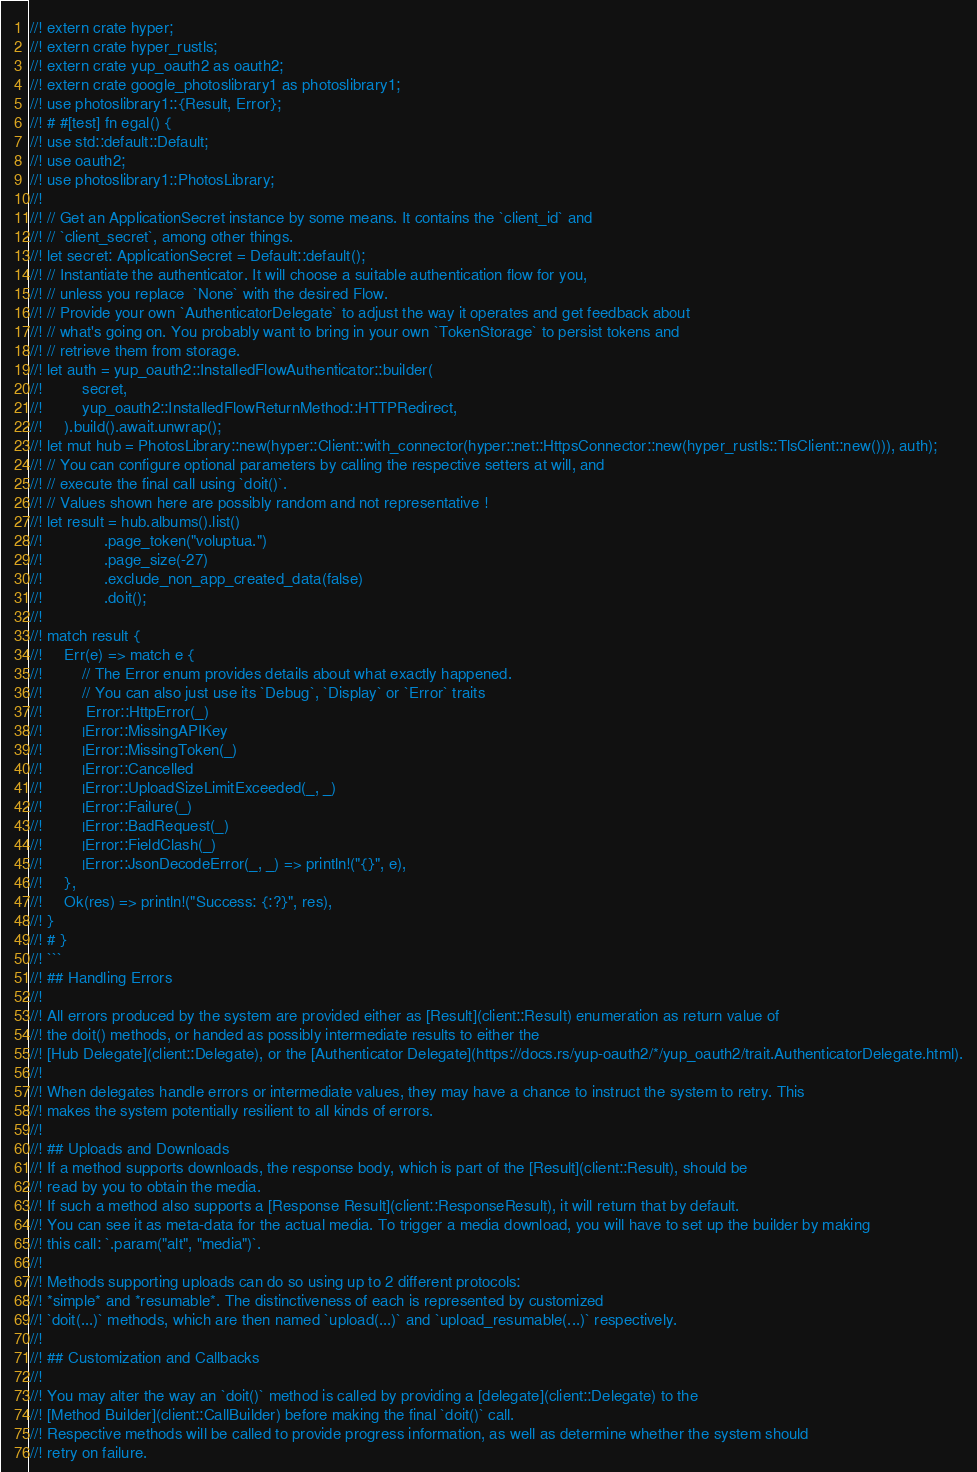Convert code to text. <code><loc_0><loc_0><loc_500><loc_500><_Rust_>//! extern crate hyper;
//! extern crate hyper_rustls;
//! extern crate yup_oauth2 as oauth2;
//! extern crate google_photoslibrary1 as photoslibrary1;
//! use photoslibrary1::{Result, Error};
//! # #[test] fn egal() {
//! use std::default::Default;
//! use oauth2;
//! use photoslibrary1::PhotosLibrary;
//! 
//! // Get an ApplicationSecret instance by some means. It contains the `client_id` and 
//! // `client_secret`, among other things.
//! let secret: ApplicationSecret = Default::default();
//! // Instantiate the authenticator. It will choose a suitable authentication flow for you, 
//! // unless you replace  `None` with the desired Flow.
//! // Provide your own `AuthenticatorDelegate` to adjust the way it operates and get feedback about 
//! // what's going on. You probably want to bring in your own `TokenStorage` to persist tokens and
//! // retrieve them from storage.
//! let auth = yup_oauth2::InstalledFlowAuthenticator::builder(
//!         secret,
//!         yup_oauth2::InstalledFlowReturnMethod::HTTPRedirect,
//!     ).build().await.unwrap();
//! let mut hub = PhotosLibrary::new(hyper::Client::with_connector(hyper::net::HttpsConnector::new(hyper_rustls::TlsClient::new())), auth);
//! // You can configure optional parameters by calling the respective setters at will, and
//! // execute the final call using `doit()`.
//! // Values shown here are possibly random and not representative !
//! let result = hub.albums().list()
//!              .page_token("voluptua.")
//!              .page_size(-27)
//!              .exclude_non_app_created_data(false)
//!              .doit();
//! 
//! match result {
//!     Err(e) => match e {
//!         // The Error enum provides details about what exactly happened.
//!         // You can also just use its `Debug`, `Display` or `Error` traits
//!          Error::HttpError(_)
//!         |Error::MissingAPIKey
//!         |Error::MissingToken(_)
//!         |Error::Cancelled
//!         |Error::UploadSizeLimitExceeded(_, _)
//!         |Error::Failure(_)
//!         |Error::BadRequest(_)
//!         |Error::FieldClash(_)
//!         |Error::JsonDecodeError(_, _) => println!("{}", e),
//!     },
//!     Ok(res) => println!("Success: {:?}", res),
//! }
//! # }
//! ```
//! ## Handling Errors
//! 
//! All errors produced by the system are provided either as [Result](client::Result) enumeration as return value of
//! the doit() methods, or handed as possibly intermediate results to either the 
//! [Hub Delegate](client::Delegate), or the [Authenticator Delegate](https://docs.rs/yup-oauth2/*/yup_oauth2/trait.AuthenticatorDelegate.html).
//! 
//! When delegates handle errors or intermediate values, they may have a chance to instruct the system to retry. This 
//! makes the system potentially resilient to all kinds of errors.
//! 
//! ## Uploads and Downloads
//! If a method supports downloads, the response body, which is part of the [Result](client::Result), should be
//! read by you to obtain the media.
//! If such a method also supports a [Response Result](client::ResponseResult), it will return that by default.
//! You can see it as meta-data for the actual media. To trigger a media download, you will have to set up the builder by making
//! this call: `.param("alt", "media")`.
//! 
//! Methods supporting uploads can do so using up to 2 different protocols: 
//! *simple* and *resumable*. The distinctiveness of each is represented by customized 
//! `doit(...)` methods, which are then named `upload(...)` and `upload_resumable(...)` respectively.
//! 
//! ## Customization and Callbacks
//! 
//! You may alter the way an `doit()` method is called by providing a [delegate](client::Delegate) to the 
//! [Method Builder](client::CallBuilder) before making the final `doit()` call. 
//! Respective methods will be called to provide progress information, as well as determine whether the system should 
//! retry on failure.</code> 